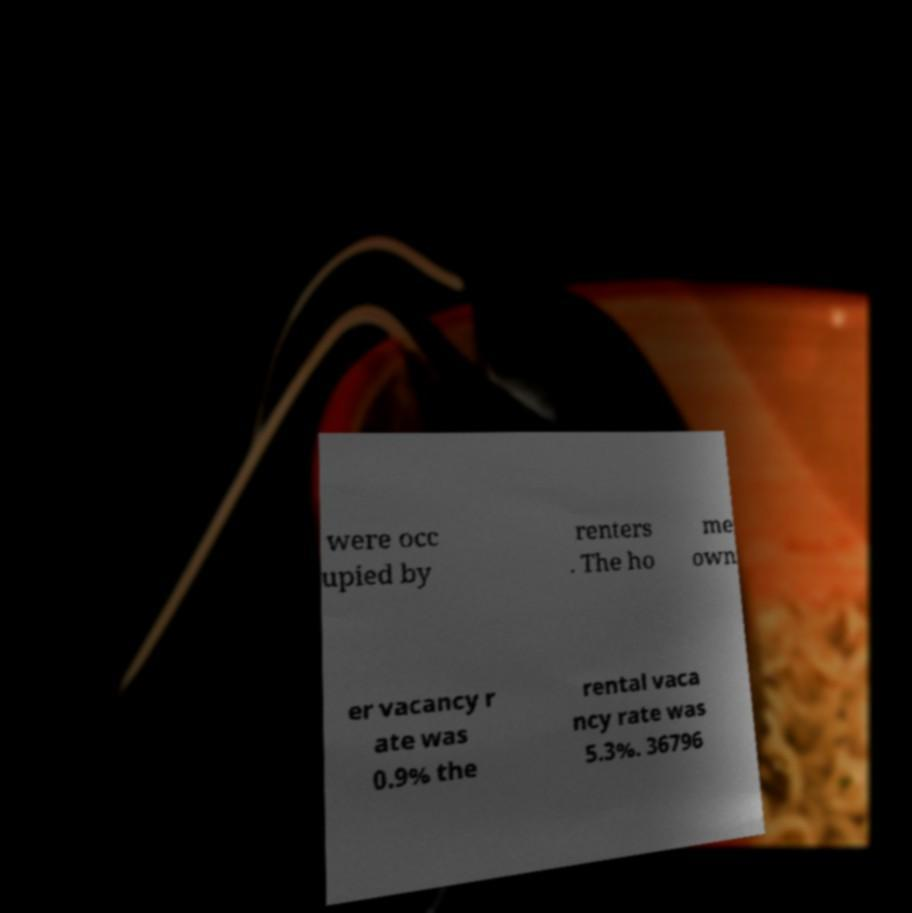What messages or text are displayed in this image? I need them in a readable, typed format. were occ upied by renters . The ho me own er vacancy r ate was 0.9% the rental vaca ncy rate was 5.3%. 36796 